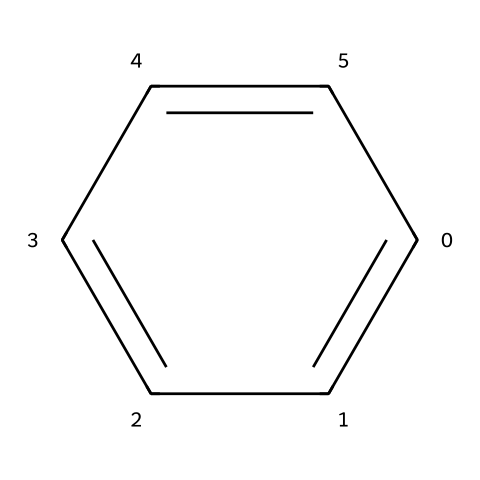What is the molecular formula of benzene? Benzene consists of six carbon atoms and six hydrogen atoms, which is represented by the formula C6H6.
Answer: C6H6 How many hydrogen atoms are bonded to carbon in benzene? In the benzene structure, each carbon atom is bonded to one hydrogen atom, leading to a total of six hydrogen atoms.
Answer: six What type of bonding is present in benzene? Benzene features alternating single and double bonds known as resonance, but as a whole, it is characterized by delocalized electrons forming pi bonds across the ring.
Answer: resonance How many carbon atoms are in benzene? The visual representation indicates there are six carbon atoms forming a cyclic structure with alternating bonds.
Answer: six What is the classification of benzene in terms of hydrocarbon types? Benzene is classified as an aromatic hydrocarbon due to its cyclic structure and delocalized pi electrons that give it stability and unique properties.
Answer: aromatic What is the characteristic property of benzene related to its stability? The delocalization of electrons across the six carbon atoms leads to increased stability compared to aliphatic hydrocarbons, a property known as aromaticity.
Answer: aromaticity What kind of reactions is benzene most likely to undergo? Benzene generally undergoes substitution reactions rather than addition reactions, preserving its aromatic ring.
Answer: substitution 